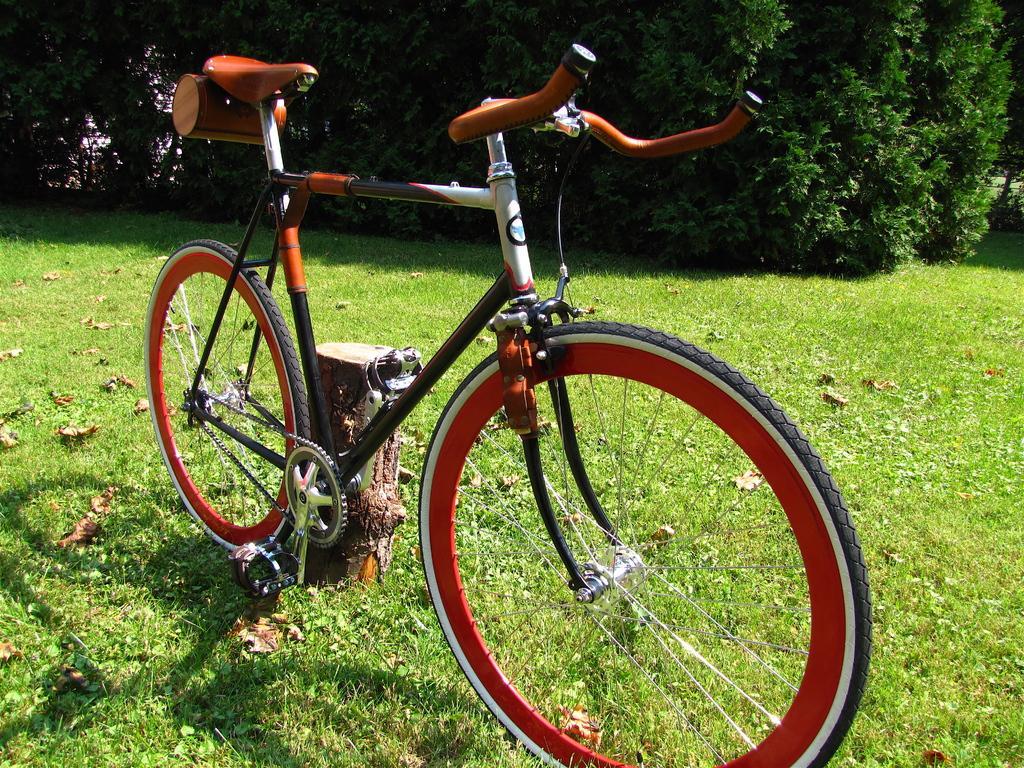Describe this image in one or two sentences. In this image, we can see a bicycle is parked on the grass near the wooden pole. Top of the image, we can see so many plants. 